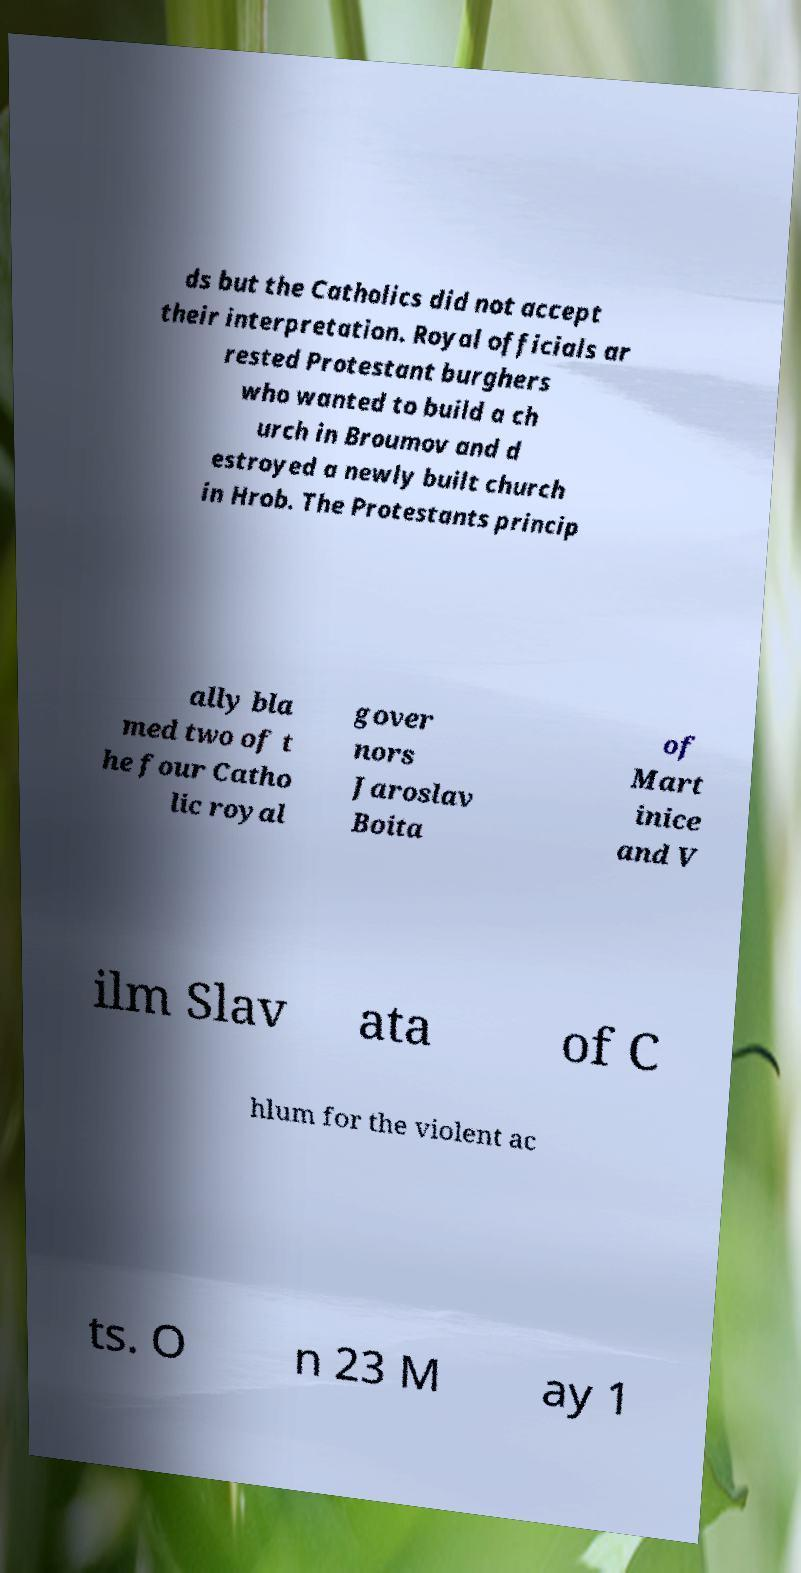Please identify and transcribe the text found in this image. ds but the Catholics did not accept their interpretation. Royal officials ar rested Protestant burghers who wanted to build a ch urch in Broumov and d estroyed a newly built church in Hrob. The Protestants princip ally bla med two of t he four Catho lic royal gover nors Jaroslav Boita of Mart inice and V ilm Slav ata of C hlum for the violent ac ts. O n 23 M ay 1 